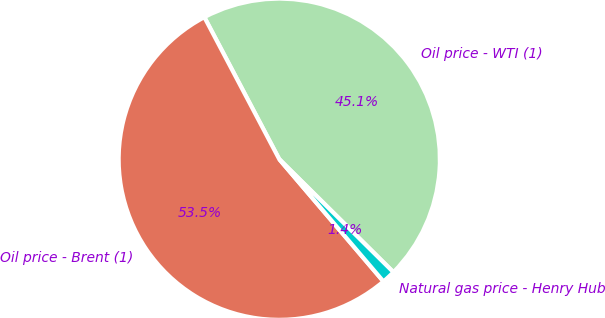Convert chart to OTSL. <chart><loc_0><loc_0><loc_500><loc_500><pie_chart><fcel>Oil price - WTI (1)<fcel>Oil price - Brent (1)<fcel>Natural gas price - Henry Hub<nl><fcel>45.14%<fcel>53.51%<fcel>1.35%<nl></chart> 